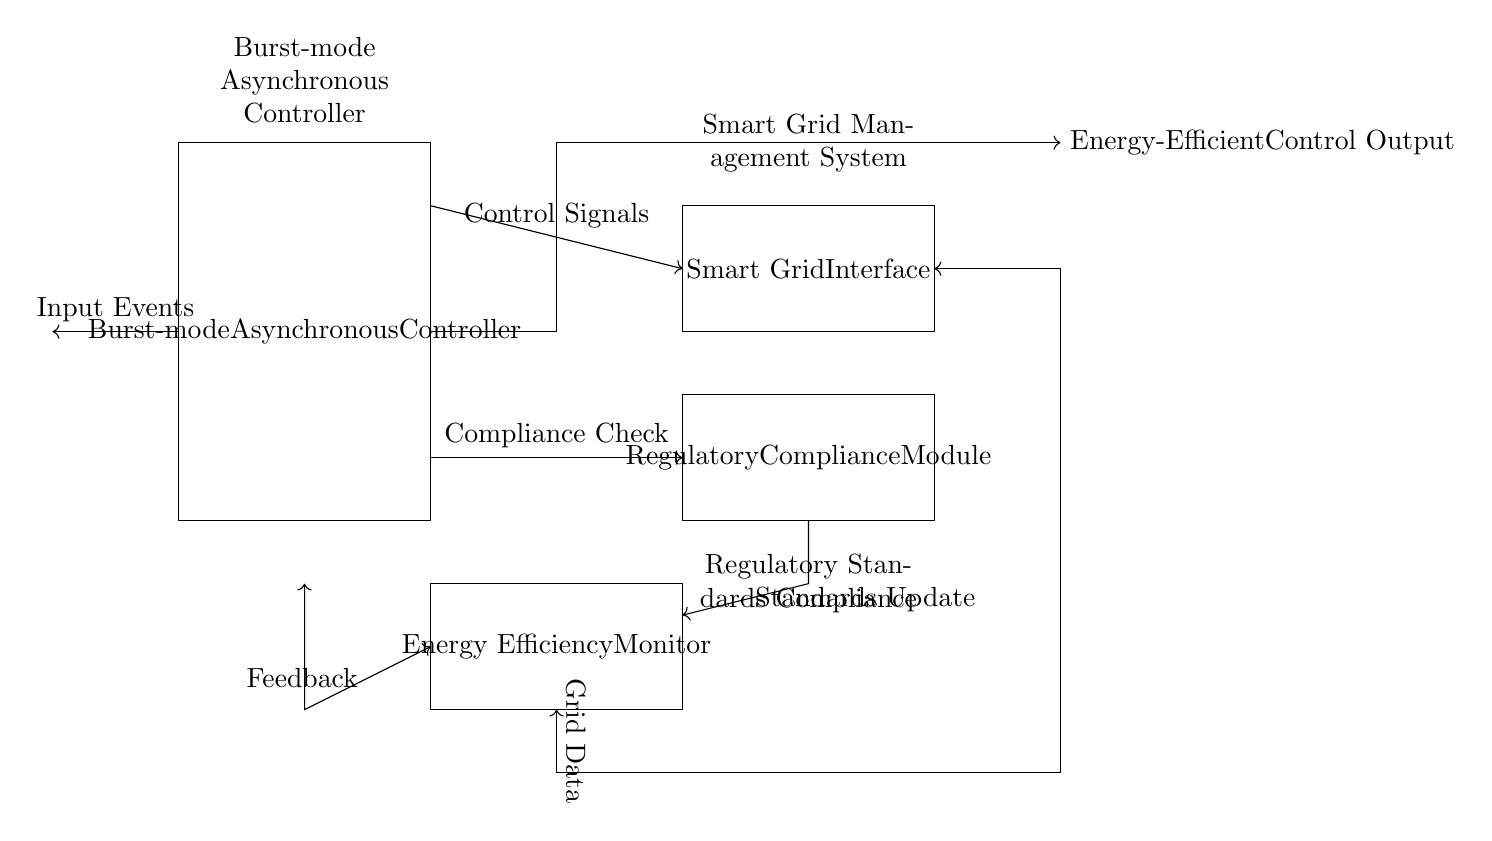What is the main component shown in the circuit? The main component indicated in the diagram is the "Burst-mode Asynchronous Controller," which occupies the largest rectangle.
Answer: Burst-mode Asynchronous Controller What are the two interfaces connected to the controller? The diagram shows two rectangles connected to the Burst-mode Asynchronous Controller: one labeled "Smart Grid Interface" and the other labeled "Regulatory Compliance Module." The names of these components indicate what they are designed to interact with.
Answer: Smart Grid Interface and Regulatory Compliance Module How do control signals flow in the circuit? Control signals flow from the "Burst-mode Asynchronous Controller" to the "Smart Grid Interface," as indicated by the arrow showing the direction of connection. This flow indicates the controller's output signals are directing the interface.
Answer: To Smart Grid Interface What type of feedback is mentioned in the circuit? The diagram specifies "Feedback" as a connection between the "Energy Efficiency Monitor" and the controller. This indicates that the monitor sends data back to the controller to adjust its operations based on energy efficiency measures.
Answer: Feedback What regulatory aspect is checked in the diagram? The "Regulatory Compliance Module" checks for compliance, which is shown as an arrow connecting this module to the controller indicating a compliance check process. This suggests that the module evaluates if the system adheres to established standards.
Answer: Compliance Check What's indicated by the standards update in the circuit? The line labeled "Standards Update" indicates a flow of information from the "Regulatory Compliance Module" to the controller, implying that updates regarding regulatory standards are sent to the controller to ensure compliance with current rules.
Answer: Standards Update How does grid data interact with the circuit? Grid data enters the circuit through a double-headed arrow connecting the "Smart Grid Interface" to the "Burst-mode Asynchronous Controller." This indicates a bidirectional communication where data from the grid influences the controller's operations and vice versa.
Answer: Grid Data 